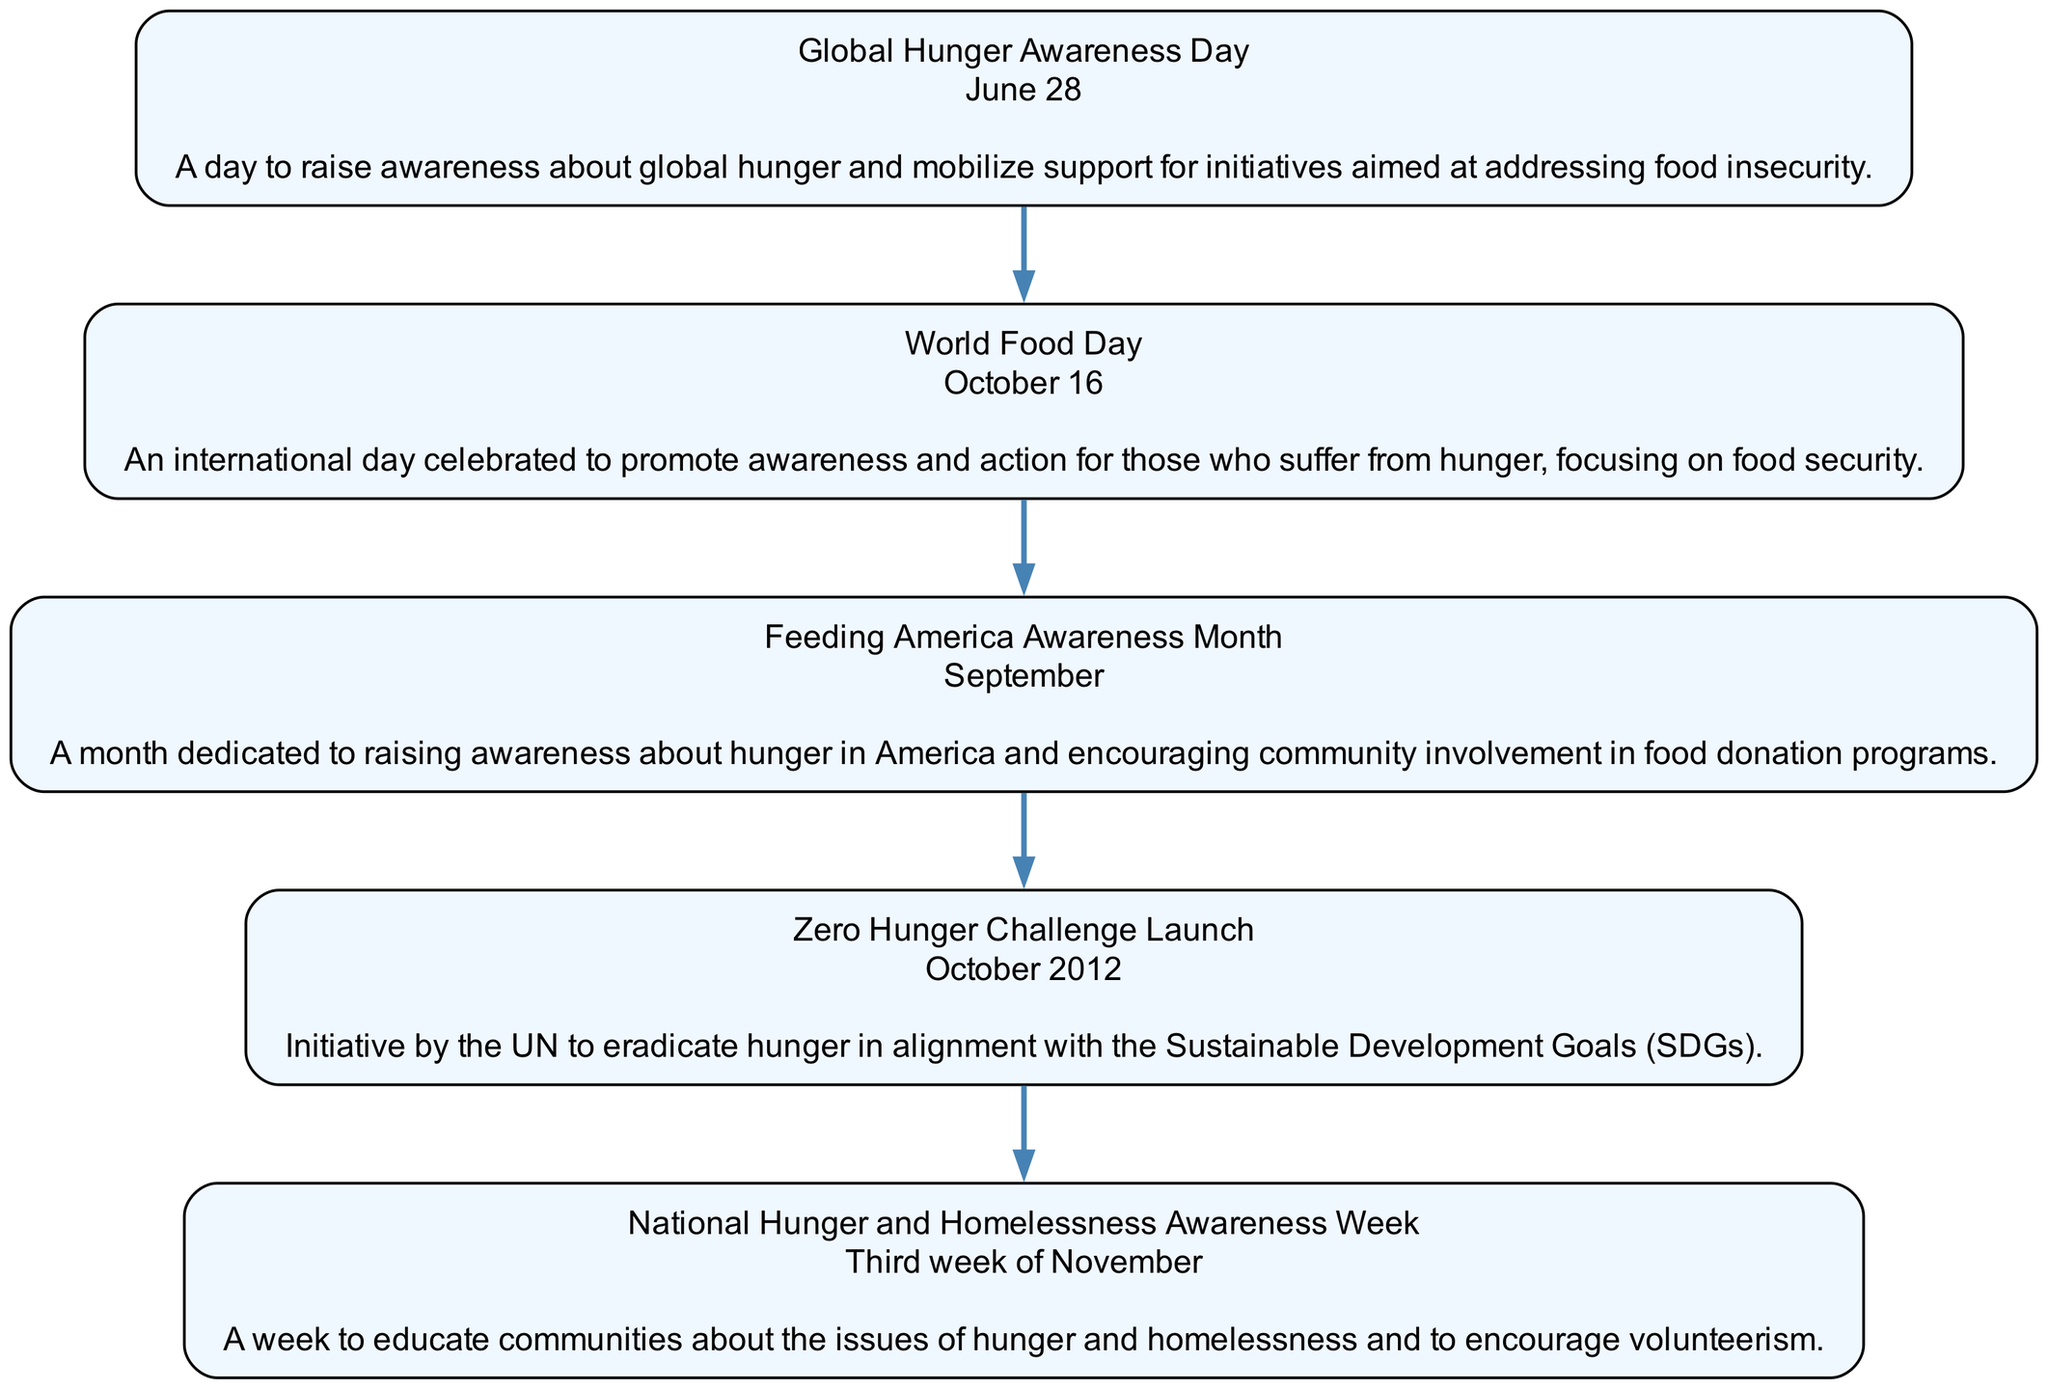What is the date of Global Hunger Awareness Day? The diagram specifies that Global Hunger Awareness Day occurs on June 28. This is found in the first event node, which includes both the event name and its corresponding date.
Answer: June 28 How many total events are listed in the timeline? The timeline includes five distinct events that are each represented as nodes in the diagram. Thus, by counting the nodes, we determine the total number of events.
Answer: 5 What event is recognized in October? The diagram indicates two events recognized in October: World Food Day (October 16) and the Zero Hunger Challenge Launch (October 2012). However, the key event that is specifically stated as occurring in October is World Food Day.
Answer: World Food Day What is the focus of Feeding America Awareness Month? According to the description in its corresponding node, Feeding America Awareness Month is dedicated to raising awareness about hunger in America and promoting community involvement in food donation programs. Thus, the main focus is on food donation initiatives.
Answer: Food donation How does National Hunger and Homelessness Awareness Week aim to educate communities? The diagram explains that National Hunger and Homelessness Awareness Week aims to educate communities about the issues of hunger and homelessness while encouraging volunteerism. Thus, education is primarily focused on these two issues, supported by community action.
Answer: By educating about hunger and homelessness In which month is National Hunger and Homelessness Awareness Week observed? The third week of November is designated for National Hunger and Homelessness Awareness Week. This information appears as part of the event description in the timeline.
Answer: November What do the Global Hunger Awareness Day and World Food Day have in common? Both events aim to raise awareness about hunger-related issues. The first focuses on global hunger, while the second targets food security. By examining the descriptions of both events, we see that their commonality lies in their purpose of awareness-raising.
Answer: Awareness of hunger What significant initiative was launched in October 2012? The Zero Hunger Challenge was launched in October 2012 according to the event’s description in the timeline. This initiative aims to eradicate hunger and is aligned with the Sustainable Development Goals.
Answer: Zero Hunger Challenge 